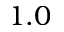Convert formula to latex. <formula><loc_0><loc_0><loc_500><loc_500>1 . 0</formula> 